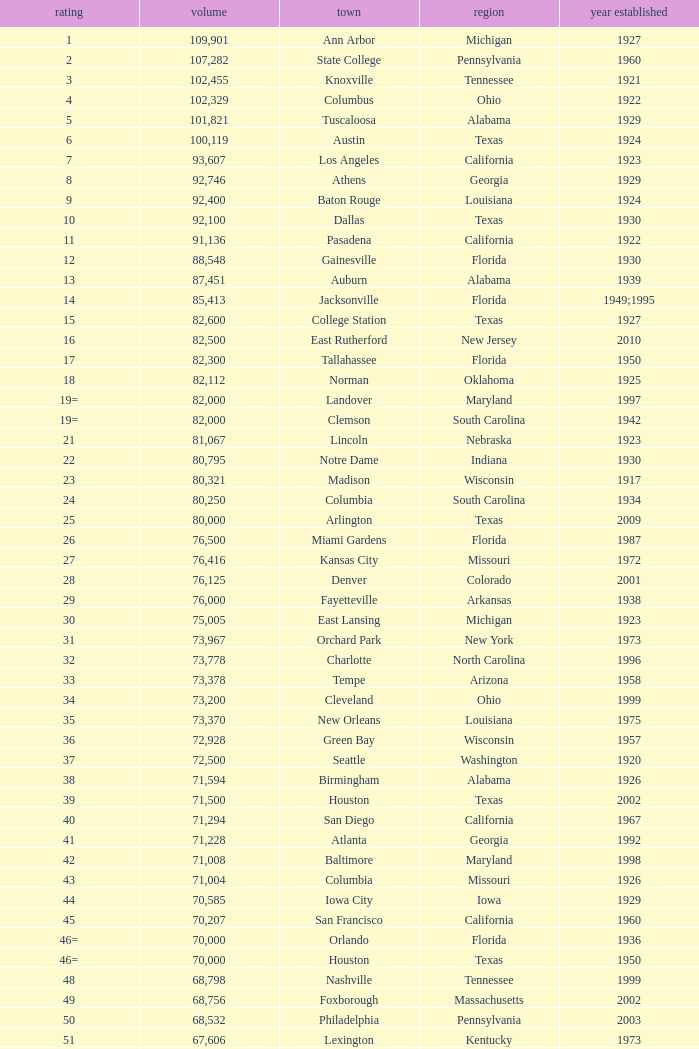What is the city in Alabama that opened in 1996? Huntsville. Parse the full table. {'header': ['rating', 'volume', 'town', 'region', 'year established'], 'rows': [['1', '109,901', 'Ann Arbor', 'Michigan', '1927'], ['2', '107,282', 'State College', 'Pennsylvania', '1960'], ['3', '102,455', 'Knoxville', 'Tennessee', '1921'], ['4', '102,329', 'Columbus', 'Ohio', '1922'], ['5', '101,821', 'Tuscaloosa', 'Alabama', '1929'], ['6', '100,119', 'Austin', 'Texas', '1924'], ['7', '93,607', 'Los Angeles', 'California', '1923'], ['8', '92,746', 'Athens', 'Georgia', '1929'], ['9', '92,400', 'Baton Rouge', 'Louisiana', '1924'], ['10', '92,100', 'Dallas', 'Texas', '1930'], ['11', '91,136', 'Pasadena', 'California', '1922'], ['12', '88,548', 'Gainesville', 'Florida', '1930'], ['13', '87,451', 'Auburn', 'Alabama', '1939'], ['14', '85,413', 'Jacksonville', 'Florida', '1949;1995'], ['15', '82,600', 'College Station', 'Texas', '1927'], ['16', '82,500', 'East Rutherford', 'New Jersey', '2010'], ['17', '82,300', 'Tallahassee', 'Florida', '1950'], ['18', '82,112', 'Norman', 'Oklahoma', '1925'], ['19=', '82,000', 'Landover', 'Maryland', '1997'], ['19=', '82,000', 'Clemson', 'South Carolina', '1942'], ['21', '81,067', 'Lincoln', 'Nebraska', '1923'], ['22', '80,795', 'Notre Dame', 'Indiana', '1930'], ['23', '80,321', 'Madison', 'Wisconsin', '1917'], ['24', '80,250', 'Columbia', 'South Carolina', '1934'], ['25', '80,000', 'Arlington', 'Texas', '2009'], ['26', '76,500', 'Miami Gardens', 'Florida', '1987'], ['27', '76,416', 'Kansas City', 'Missouri', '1972'], ['28', '76,125', 'Denver', 'Colorado', '2001'], ['29', '76,000', 'Fayetteville', 'Arkansas', '1938'], ['30', '75,005', 'East Lansing', 'Michigan', '1923'], ['31', '73,967', 'Orchard Park', 'New York', '1973'], ['32', '73,778', 'Charlotte', 'North Carolina', '1996'], ['33', '73,378', 'Tempe', 'Arizona', '1958'], ['34', '73,200', 'Cleveland', 'Ohio', '1999'], ['35', '73,370', 'New Orleans', 'Louisiana', '1975'], ['36', '72,928', 'Green Bay', 'Wisconsin', '1957'], ['37', '72,500', 'Seattle', 'Washington', '1920'], ['38', '71,594', 'Birmingham', 'Alabama', '1926'], ['39', '71,500', 'Houston', 'Texas', '2002'], ['40', '71,294', 'San Diego', 'California', '1967'], ['41', '71,228', 'Atlanta', 'Georgia', '1992'], ['42', '71,008', 'Baltimore', 'Maryland', '1998'], ['43', '71,004', 'Columbia', 'Missouri', '1926'], ['44', '70,585', 'Iowa City', 'Iowa', '1929'], ['45', '70,207', 'San Francisco', 'California', '1960'], ['46=', '70,000', 'Orlando', 'Florida', '1936'], ['46=', '70,000', 'Houston', 'Texas', '1950'], ['48', '68,798', 'Nashville', 'Tennessee', '1999'], ['49', '68,756', 'Foxborough', 'Massachusetts', '2002'], ['50', '68,532', 'Philadelphia', 'Pennsylvania', '2003'], ['51', '67,606', 'Lexington', 'Kentucky', '1973'], ['52', '67,000', 'Seattle', 'Washington', '2002'], ['53', '66,965', 'St. Louis', 'Missouri', '1995'], ['54', '66,233', 'Blacksburg', 'Virginia', '1965'], ['55', '65,857', 'Tampa', 'Florida', '1998'], ['56', '65,790', 'Cincinnati', 'Ohio', '2000'], ['57', '65,050', 'Pittsburgh', 'Pennsylvania', '2001'], ['58=', '65,000', 'San Antonio', 'Texas', '1993'], ['58=', '65,000', 'Detroit', 'Michigan', '2002'], ['60', '64,269', 'New Haven', 'Connecticut', '1914'], ['61', '64,111', 'Minneapolis', 'Minnesota', '1982'], ['62', '64,045', 'Provo', 'Utah', '1964'], ['63', '63,400', 'Glendale', 'Arizona', '2006'], ['64', '63,026', 'Oakland', 'California', '1966'], ['65', '63,000', 'Indianapolis', 'Indiana', '2008'], ['65', '63.000', 'Chapel Hill', 'North Carolina', '1926'], ['66', '62,872', 'Champaign', 'Illinois', '1923'], ['67', '62,717', 'Berkeley', 'California', '1923'], ['68', '61,500', 'Chicago', 'Illinois', '1924;2003'], ['69', '62,500', 'West Lafayette', 'Indiana', '1924'], ['70', '62,380', 'Memphis', 'Tennessee', '1965'], ['71', '61,500', 'Charlottesville', 'Virginia', '1931'], ['72', '61,000', 'Lubbock', 'Texas', '1947'], ['73', '60,580', 'Oxford', 'Mississippi', '1915'], ['74', '60,540', 'Morgantown', 'West Virginia', '1980'], ['75', '60,492', 'Jackson', 'Mississippi', '1941'], ['76', '60,000', 'Stillwater', 'Oklahoma', '1920'], ['78', '57,803', 'Tucson', 'Arizona', '1928'], ['79', '57,583', 'Raleigh', 'North Carolina', '1966'], ['80', '56,692', 'Washington, D.C.', 'District of Columbia', '1961'], ['81=', '56,000', 'Los Angeles', 'California', '1962'], ['81=', '56,000', 'Louisville', 'Kentucky', '1998'], ['83', '55,082', 'Starkville', 'Mississippi', '1914'], ['84=', '55,000', 'Atlanta', 'Georgia', '1913'], ['84=', '55,000', 'Ames', 'Iowa', '1975'], ['86', '53,800', 'Eugene', 'Oregon', '1967'], ['87', '53,750', 'Boulder', 'Colorado', '1924'], ['88', '53,727', 'Little Rock', 'Arkansas', '1948'], ['89', '53,500', 'Bloomington', 'Indiana', '1960'], ['90', '52,593', 'Philadelphia', 'Pennsylvania', '1895'], ['91', '52,480', 'Colorado Springs', 'Colorado', '1962'], ['92', '52,454', 'Piscataway', 'New Jersey', '1994'], ['93', '52,200', 'Manhattan', 'Kansas', '1968'], ['94=', '51,500', 'College Park', 'Maryland', '1950'], ['94=', '51,500', 'El Paso', 'Texas', '1963'], ['96', '50,832', 'Shreveport', 'Louisiana', '1925'], ['97', '50,805', 'Minneapolis', 'Minnesota', '2009'], ['98', '50,445', 'Denver', 'Colorado', '1995'], ['99', '50,291', 'Bronx', 'New York', '2009'], ['100', '50,096', 'Atlanta', 'Georgia', '1996'], ['101', '50,071', 'Lawrence', 'Kansas', '1921'], ['102=', '50,000', 'Honolulu', 'Hawai ʻ i', '1975'], ['102=', '50,000', 'Greenville', 'North Carolina', '1963'], ['102=', '50,000', 'Waco', 'Texas', '1950'], ['102=', '50,000', 'Stanford', 'California', '1921;2006'], ['106', '49,262', 'Syracuse', 'New York', '1980'], ['107', '49,115', 'Arlington', 'Texas', '1994'], ['108', '49,033', 'Phoenix', 'Arizona', '1998'], ['109', '48,876', 'Baltimore', 'Maryland', '1992'], ['110', '47,130', 'Evanston', 'Illinois', '1996'], ['111', '47,116', 'Seattle', 'Washington', '1999'], ['112', '46,861', 'St. Louis', 'Missouri', '2006'], ['113', '45,674', 'Corvallis', 'Oregon', '1953'], ['114', '45,634', 'Salt Lake City', 'Utah', '1998'], ['115', '45,301', 'Orlando', 'Florida', '2007'], ['116', '45,050', 'Anaheim', 'California', '1966'], ['117', '44,500', 'Chestnut Hill', 'Massachusetts', '1957'], ['118', '44,008', 'Fort Worth', 'Texas', '1930'], ['119', '43,647', 'Philadelphia', 'Pennsylvania', '2004'], ['120', '43,545', 'Cleveland', 'Ohio', '1994'], ['121', '42,445', 'San Diego', 'California', '2004'], ['122', '42,059', 'Cincinnati', 'Ohio', '2003'], ['123', '41,900', 'Milwaukee', 'Wisconsin', '2001'], ['124', '41,888', 'Washington, D.C.', 'District of Columbia', '2008'], ['125', '41,800', 'Flushing, New York', 'New York', '2009'], ['126', '41,782', 'Detroit', 'Michigan', '2000'], ['127', '41,503', 'San Francisco', 'California', '2000'], ['128', '41,160', 'Chicago', 'Illinois', '1914'], ['129', '41,031', 'Fresno', 'California', '1980'], ['130', '40,950', 'Houston', 'Texas', '2000'], ['131', '40,646', 'Mobile', 'Alabama', '1948'], ['132', '40,615', 'Chicago', 'Illinois', '1991'], ['133', '40,094', 'Albuquerque', 'New Mexico', '1960'], ['134=', '40,000', 'South Williamsport', 'Pennsylvania', '1959'], ['134=', '40,000', 'East Hartford', 'Connecticut', '2003'], ['134=', '40,000', 'West Point', 'New York', '1924'], ['137', '39,790', 'Nashville', 'Tennessee', '1922'], ['138', '39,504', 'Minneapolis', 'Minnesota', '2010'], ['139', '39,000', 'Kansas City', 'Missouri', '1973'], ['140', '38,496', 'Pittsburgh', 'Pennsylvania', '2001'], ['141', '38,019', 'Huntington', 'West Virginia', '1991'], ['142', '37,402', 'Boston', 'Massachusetts', '1912'], ['143=', '37,000', 'Boise', 'Idaho', '1970'], ['143=', '37,000', 'Miami', 'Florida', '2012'], ['145', '36,973', 'St. Petersburg', 'Florida', '1990'], ['146', '36,800', 'Whitney', 'Nevada', '1971'], ['147', '36,000', 'Hattiesburg', 'Mississippi', '1932'], ['148', '35,117', 'Pullman', 'Washington', '1972'], ['149', '35,097', 'Cincinnati', 'Ohio', '1924'], ['150', '34,400', 'Fort Collins', 'Colorado', '1968'], ['151', '34,000', 'Annapolis', 'Maryland', '1959'], ['152', '33,941', 'Durham', 'North Carolina', '1929'], ['153', '32,580', 'Laramie', 'Wyoming', '1950'], ['154=', '32,000', 'University Park', 'Texas', '2000'], ['154=', '32,000', 'Houston', 'Texas', '1942'], ['156', '31,500', 'Winston-Salem', 'North Carolina', '1968'], ['157=', '31,000', 'Lafayette', 'Louisiana', '1971'], ['157=', '31,000', 'Akron', 'Ohio', '1940'], ['157=', '31,000', 'DeKalb', 'Illinois', '1965'], ['160', '30,964', 'Jonesboro', 'Arkansas', '1974'], ['161', '30,850', 'Denton', 'Texas', '2011'], ['162', '30,600', 'Ruston', 'Louisiana', '1960'], ['163', '30,456', 'San Jose', 'California', '1933'], ['164', '30,427', 'Monroe', 'Louisiana', '1978'], ['165', '30,343', 'Las Cruces', 'New Mexico', '1978'], ['166', '30,323', 'Allston', 'Massachusetts', '1903'], ['167', '30,295', 'Mount Pleasant', 'Michigan', '1972'], ['168=', '30,200', 'Ypsilanti', 'Michigan', '1969'], ['168=', '30,200', 'Kalamazoo', 'Michigan', '1939'], ['168=', '30,000', 'Boca Raton', 'Florida', '2011'], ['168=', '30,000', 'San Marcos', 'Texas', '1981'], ['168=', '30,000', 'Tulsa', 'Oklahoma', '1930'], ['168=', '30,000', 'Akron', 'Ohio', '2009'], ['168=', '30,000', 'Troy', 'Alabama', '1950'], ['168=', '30,000', 'Norfolk', 'Virginia', '1997'], ['176', '29,993', 'Reno', 'Nevada', '1966'], ['177', '29,013', 'Amherst', 'New York', '1993'], ['178', '29,000', 'Baton Rouge', 'Louisiana', '1928'], ['179', '28,646', 'Spokane', 'Washington', '1950'], ['180', '27,800', 'Princeton', 'New Jersey', '1998'], ['181', '27,000', 'Carson', 'California', '2003'], ['182', '26,248', 'Toledo', 'Ohio', '1937'], ['183', '25,600', 'Grambling', 'Louisiana', '1983'], ['184', '25,597', 'Ithaca', 'New York', '1915'], ['185', '25,500', 'Tallahassee', 'Florida', '1957'], ['186', '25,400', 'Muncie', 'Indiana', '1967'], ['187', '25,200', 'Missoula', 'Montana', '1986'], ['188', '25,189', 'Harrison', 'New Jersey', '2010'], ['189', '25,000', 'Kent', 'Ohio', '1969'], ['190', '24,877', 'Harrisonburg', 'Virginia', '1975'], ['191', '24,600', 'Montgomery', 'Alabama', '1922'], ['192', '24,286', 'Oxford', 'Ohio', '1983'], ['193=', '24,000', 'Omaha', 'Nebraska', '2011'], ['193=', '24,000', 'Athens', 'Ohio', '1929'], ['194', '23,724', 'Bowling Green', 'Ohio', '1966'], ['195', '23,500', 'Worcester', 'Massachusetts', '1924'], ['196', '22,500', 'Lorman', 'Mississippi', '1992'], ['197=', '22,000', 'Houston', 'Texas', '2012'], ['197=', '22,000', 'Newark', 'Delaware', '1952'], ['197=', '22,000', 'Bowling Green', 'Kentucky', '1968'], ['197=', '22,000', 'Orangeburg', 'South Carolina', '1955'], ['201', '21,650', 'Boone', 'North Carolina', '1962'], ['202', '21,500', 'Greensboro', 'North Carolina', '1981'], ['203', '21,650', 'Sacramento', 'California', '1969'], ['204=', '21,000', 'Charleston', 'South Carolina', '1946'], ['204=', '21,000', 'Huntsville', 'Alabama', '1996'], ['204=', '21,000', 'Chicago', 'Illinois', '1994'], ['207', '20,668', 'Chattanooga', 'Tennessee', '1997'], ['208', '20,630', 'Youngstown', 'Ohio', '1982'], ['209', '20,500', 'Frisco', 'Texas', '2005'], ['210', '20,455', 'Columbus', 'Ohio', '1999'], ['211', '20,450', 'Fort Lauderdale', 'Florida', '1959'], ['212', '20,438', 'Portland', 'Oregon', '1926'], ['213', '20,311', 'Sacramento, California', 'California', '1928'], ['214', '20,066', 'Detroit, Michigan', 'Michigan', '1979'], ['215', '20,008', 'Sandy', 'Utah', '2008'], ['216=', '20,000', 'Providence', 'Rhode Island', '1925'], ['216=', '20,000', 'Miami', 'Florida', '1995'], ['216=', '20,000', 'Richmond', 'Kentucky', '1969'], ['216=', '20,000', 'Mesquite', 'Texas', '1977'], ['216=', '20,000', 'Canyon', 'Texas', '1959'], ['216=', '20,000', 'Bridgeview', 'Illinois', '2006']]} 